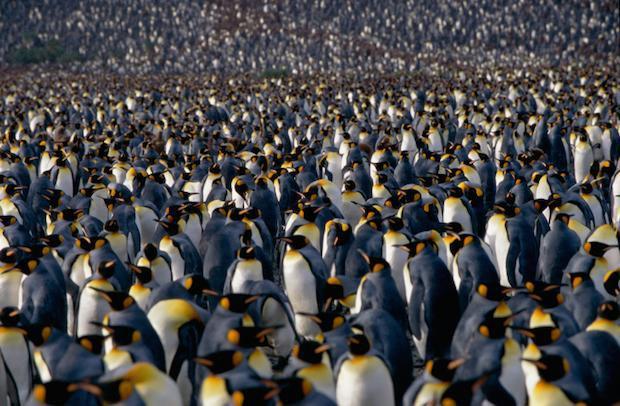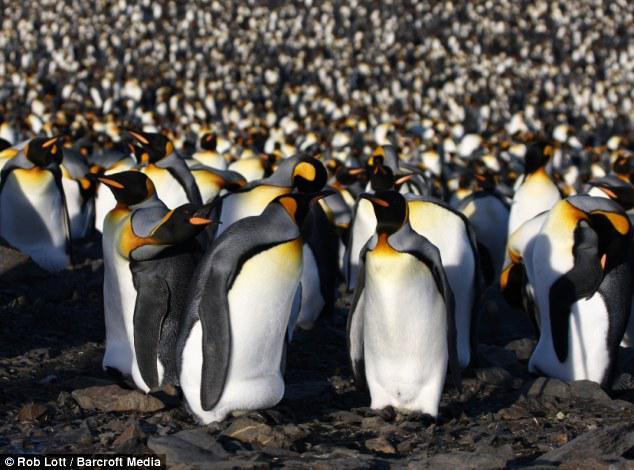The first image is the image on the left, the second image is the image on the right. Examine the images to the left and right. Is the description "The ground is visible in the image on the right." accurate? Answer yes or no. Yes. 